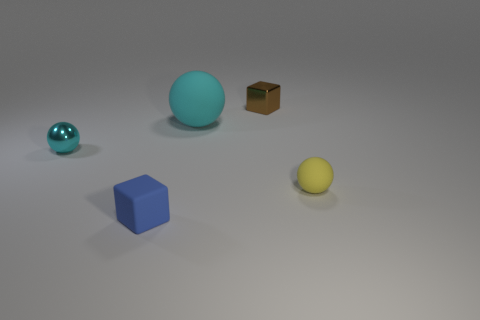Add 2 large brown cylinders. How many objects exist? 7 Subtract all balls. How many objects are left? 2 Subtract all metal objects. Subtract all blue things. How many objects are left? 2 Add 1 big cyan spheres. How many big cyan spheres are left? 2 Add 2 small rubber objects. How many small rubber objects exist? 4 Subtract 0 purple cylinders. How many objects are left? 5 